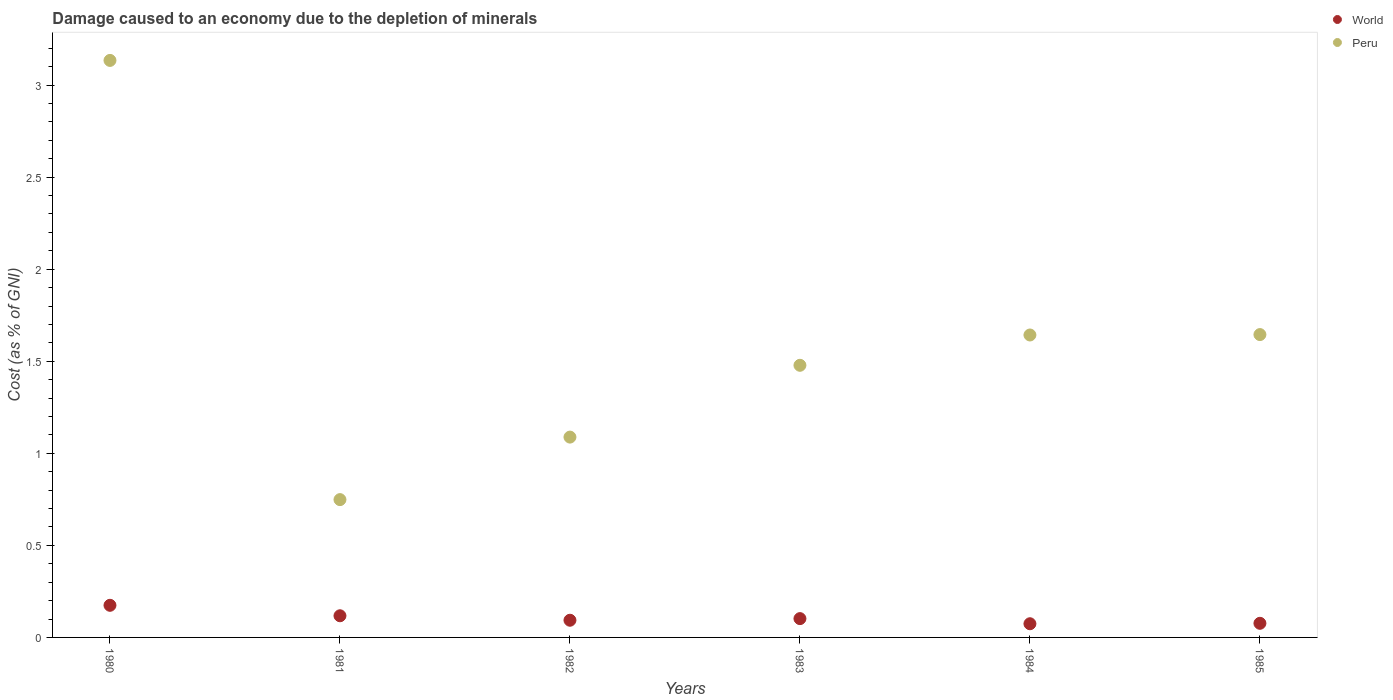Is the number of dotlines equal to the number of legend labels?
Keep it short and to the point. Yes. What is the cost of damage caused due to the depletion of minerals in Peru in 1981?
Ensure brevity in your answer.  0.75. Across all years, what is the maximum cost of damage caused due to the depletion of minerals in Peru?
Offer a very short reply. 3.13. Across all years, what is the minimum cost of damage caused due to the depletion of minerals in Peru?
Keep it short and to the point. 0.75. In which year was the cost of damage caused due to the depletion of minerals in World minimum?
Keep it short and to the point. 1984. What is the total cost of damage caused due to the depletion of minerals in World in the graph?
Your answer should be very brief. 0.64. What is the difference between the cost of damage caused due to the depletion of minerals in Peru in 1980 and that in 1982?
Your response must be concise. 2.05. What is the difference between the cost of damage caused due to the depletion of minerals in World in 1984 and the cost of damage caused due to the depletion of minerals in Peru in 1980?
Provide a short and direct response. -3.06. What is the average cost of damage caused due to the depletion of minerals in Peru per year?
Offer a very short reply. 1.62. In the year 1981, what is the difference between the cost of damage caused due to the depletion of minerals in Peru and cost of damage caused due to the depletion of minerals in World?
Ensure brevity in your answer.  0.63. In how many years, is the cost of damage caused due to the depletion of minerals in World greater than 2.5 %?
Offer a very short reply. 0. What is the ratio of the cost of damage caused due to the depletion of minerals in Peru in 1984 to that in 1985?
Ensure brevity in your answer.  1. Is the cost of damage caused due to the depletion of minerals in Peru in 1980 less than that in 1984?
Ensure brevity in your answer.  No. Is the difference between the cost of damage caused due to the depletion of minerals in Peru in 1982 and 1983 greater than the difference between the cost of damage caused due to the depletion of minerals in World in 1982 and 1983?
Your answer should be very brief. No. What is the difference between the highest and the second highest cost of damage caused due to the depletion of minerals in World?
Offer a very short reply. 0.06. What is the difference between the highest and the lowest cost of damage caused due to the depletion of minerals in World?
Offer a terse response. 0.1. In how many years, is the cost of damage caused due to the depletion of minerals in World greater than the average cost of damage caused due to the depletion of minerals in World taken over all years?
Offer a terse response. 2. Is the sum of the cost of damage caused due to the depletion of minerals in Peru in 1984 and 1985 greater than the maximum cost of damage caused due to the depletion of minerals in World across all years?
Provide a short and direct response. Yes. Does the cost of damage caused due to the depletion of minerals in World monotonically increase over the years?
Make the answer very short. No. Is the cost of damage caused due to the depletion of minerals in World strictly less than the cost of damage caused due to the depletion of minerals in Peru over the years?
Your response must be concise. Yes. How many dotlines are there?
Ensure brevity in your answer.  2. How many years are there in the graph?
Provide a short and direct response. 6. What is the difference between two consecutive major ticks on the Y-axis?
Your answer should be very brief. 0.5. Does the graph contain any zero values?
Your answer should be very brief. No. Does the graph contain grids?
Your response must be concise. No. Where does the legend appear in the graph?
Offer a very short reply. Top right. How are the legend labels stacked?
Your answer should be very brief. Vertical. What is the title of the graph?
Give a very brief answer. Damage caused to an economy due to the depletion of minerals. What is the label or title of the X-axis?
Your answer should be compact. Years. What is the label or title of the Y-axis?
Offer a very short reply. Cost (as % of GNI). What is the Cost (as % of GNI) of World in 1980?
Ensure brevity in your answer.  0.17. What is the Cost (as % of GNI) in Peru in 1980?
Your response must be concise. 3.13. What is the Cost (as % of GNI) of World in 1981?
Give a very brief answer. 0.12. What is the Cost (as % of GNI) of Peru in 1981?
Keep it short and to the point. 0.75. What is the Cost (as % of GNI) in World in 1982?
Your answer should be compact. 0.09. What is the Cost (as % of GNI) of Peru in 1982?
Provide a succinct answer. 1.09. What is the Cost (as % of GNI) of World in 1983?
Offer a very short reply. 0.1. What is the Cost (as % of GNI) in Peru in 1983?
Offer a very short reply. 1.48. What is the Cost (as % of GNI) in World in 1984?
Your answer should be very brief. 0.07. What is the Cost (as % of GNI) in Peru in 1984?
Keep it short and to the point. 1.64. What is the Cost (as % of GNI) in World in 1985?
Provide a short and direct response. 0.08. What is the Cost (as % of GNI) in Peru in 1985?
Offer a terse response. 1.64. Across all years, what is the maximum Cost (as % of GNI) in World?
Your answer should be compact. 0.17. Across all years, what is the maximum Cost (as % of GNI) of Peru?
Keep it short and to the point. 3.13. Across all years, what is the minimum Cost (as % of GNI) of World?
Keep it short and to the point. 0.07. Across all years, what is the minimum Cost (as % of GNI) of Peru?
Keep it short and to the point. 0.75. What is the total Cost (as % of GNI) in World in the graph?
Ensure brevity in your answer.  0.64. What is the total Cost (as % of GNI) of Peru in the graph?
Give a very brief answer. 9.74. What is the difference between the Cost (as % of GNI) of World in 1980 and that in 1981?
Keep it short and to the point. 0.06. What is the difference between the Cost (as % of GNI) of Peru in 1980 and that in 1981?
Ensure brevity in your answer.  2.39. What is the difference between the Cost (as % of GNI) in World in 1980 and that in 1982?
Make the answer very short. 0.08. What is the difference between the Cost (as % of GNI) of Peru in 1980 and that in 1982?
Keep it short and to the point. 2.05. What is the difference between the Cost (as % of GNI) of World in 1980 and that in 1983?
Your answer should be very brief. 0.07. What is the difference between the Cost (as % of GNI) of Peru in 1980 and that in 1983?
Your response must be concise. 1.66. What is the difference between the Cost (as % of GNI) in World in 1980 and that in 1984?
Offer a terse response. 0.1. What is the difference between the Cost (as % of GNI) of Peru in 1980 and that in 1984?
Make the answer very short. 1.49. What is the difference between the Cost (as % of GNI) in World in 1980 and that in 1985?
Keep it short and to the point. 0.1. What is the difference between the Cost (as % of GNI) of Peru in 1980 and that in 1985?
Make the answer very short. 1.49. What is the difference between the Cost (as % of GNI) of World in 1981 and that in 1982?
Your response must be concise. 0.02. What is the difference between the Cost (as % of GNI) in Peru in 1981 and that in 1982?
Provide a short and direct response. -0.34. What is the difference between the Cost (as % of GNI) in World in 1981 and that in 1983?
Provide a succinct answer. 0.02. What is the difference between the Cost (as % of GNI) in Peru in 1981 and that in 1983?
Your answer should be very brief. -0.73. What is the difference between the Cost (as % of GNI) in World in 1981 and that in 1984?
Give a very brief answer. 0.04. What is the difference between the Cost (as % of GNI) of Peru in 1981 and that in 1984?
Make the answer very short. -0.89. What is the difference between the Cost (as % of GNI) in World in 1981 and that in 1985?
Your response must be concise. 0.04. What is the difference between the Cost (as % of GNI) in Peru in 1981 and that in 1985?
Offer a very short reply. -0.9. What is the difference between the Cost (as % of GNI) of World in 1982 and that in 1983?
Keep it short and to the point. -0.01. What is the difference between the Cost (as % of GNI) in Peru in 1982 and that in 1983?
Offer a terse response. -0.39. What is the difference between the Cost (as % of GNI) in World in 1982 and that in 1984?
Your answer should be very brief. 0.02. What is the difference between the Cost (as % of GNI) of Peru in 1982 and that in 1984?
Offer a terse response. -0.55. What is the difference between the Cost (as % of GNI) of World in 1982 and that in 1985?
Your answer should be compact. 0.02. What is the difference between the Cost (as % of GNI) in Peru in 1982 and that in 1985?
Your response must be concise. -0.56. What is the difference between the Cost (as % of GNI) in World in 1983 and that in 1984?
Provide a succinct answer. 0.03. What is the difference between the Cost (as % of GNI) in Peru in 1983 and that in 1984?
Keep it short and to the point. -0.16. What is the difference between the Cost (as % of GNI) of World in 1983 and that in 1985?
Provide a short and direct response. 0.03. What is the difference between the Cost (as % of GNI) of Peru in 1983 and that in 1985?
Keep it short and to the point. -0.17. What is the difference between the Cost (as % of GNI) of World in 1984 and that in 1985?
Keep it short and to the point. -0. What is the difference between the Cost (as % of GNI) of Peru in 1984 and that in 1985?
Provide a succinct answer. -0. What is the difference between the Cost (as % of GNI) in World in 1980 and the Cost (as % of GNI) in Peru in 1981?
Your answer should be very brief. -0.57. What is the difference between the Cost (as % of GNI) in World in 1980 and the Cost (as % of GNI) in Peru in 1982?
Provide a succinct answer. -0.91. What is the difference between the Cost (as % of GNI) of World in 1980 and the Cost (as % of GNI) of Peru in 1983?
Provide a succinct answer. -1.3. What is the difference between the Cost (as % of GNI) of World in 1980 and the Cost (as % of GNI) of Peru in 1984?
Your response must be concise. -1.47. What is the difference between the Cost (as % of GNI) of World in 1980 and the Cost (as % of GNI) of Peru in 1985?
Your answer should be very brief. -1.47. What is the difference between the Cost (as % of GNI) in World in 1981 and the Cost (as % of GNI) in Peru in 1982?
Your response must be concise. -0.97. What is the difference between the Cost (as % of GNI) in World in 1981 and the Cost (as % of GNI) in Peru in 1983?
Provide a succinct answer. -1.36. What is the difference between the Cost (as % of GNI) of World in 1981 and the Cost (as % of GNI) of Peru in 1984?
Offer a very short reply. -1.53. What is the difference between the Cost (as % of GNI) in World in 1981 and the Cost (as % of GNI) in Peru in 1985?
Your answer should be very brief. -1.53. What is the difference between the Cost (as % of GNI) of World in 1982 and the Cost (as % of GNI) of Peru in 1983?
Offer a terse response. -1.38. What is the difference between the Cost (as % of GNI) in World in 1982 and the Cost (as % of GNI) in Peru in 1984?
Provide a succinct answer. -1.55. What is the difference between the Cost (as % of GNI) of World in 1982 and the Cost (as % of GNI) of Peru in 1985?
Your answer should be compact. -1.55. What is the difference between the Cost (as % of GNI) of World in 1983 and the Cost (as % of GNI) of Peru in 1984?
Offer a terse response. -1.54. What is the difference between the Cost (as % of GNI) of World in 1983 and the Cost (as % of GNI) of Peru in 1985?
Your answer should be very brief. -1.54. What is the difference between the Cost (as % of GNI) in World in 1984 and the Cost (as % of GNI) in Peru in 1985?
Ensure brevity in your answer.  -1.57. What is the average Cost (as % of GNI) of World per year?
Your response must be concise. 0.11. What is the average Cost (as % of GNI) in Peru per year?
Keep it short and to the point. 1.62. In the year 1980, what is the difference between the Cost (as % of GNI) of World and Cost (as % of GNI) of Peru?
Provide a succinct answer. -2.96. In the year 1981, what is the difference between the Cost (as % of GNI) of World and Cost (as % of GNI) of Peru?
Provide a short and direct response. -0.63. In the year 1982, what is the difference between the Cost (as % of GNI) of World and Cost (as % of GNI) of Peru?
Ensure brevity in your answer.  -0.99. In the year 1983, what is the difference between the Cost (as % of GNI) in World and Cost (as % of GNI) in Peru?
Offer a terse response. -1.38. In the year 1984, what is the difference between the Cost (as % of GNI) in World and Cost (as % of GNI) in Peru?
Keep it short and to the point. -1.57. In the year 1985, what is the difference between the Cost (as % of GNI) of World and Cost (as % of GNI) of Peru?
Ensure brevity in your answer.  -1.57. What is the ratio of the Cost (as % of GNI) in World in 1980 to that in 1981?
Give a very brief answer. 1.48. What is the ratio of the Cost (as % of GNI) of Peru in 1980 to that in 1981?
Give a very brief answer. 4.19. What is the ratio of the Cost (as % of GNI) in World in 1980 to that in 1982?
Ensure brevity in your answer.  1.87. What is the ratio of the Cost (as % of GNI) of Peru in 1980 to that in 1982?
Give a very brief answer. 2.88. What is the ratio of the Cost (as % of GNI) in World in 1980 to that in 1983?
Your answer should be very brief. 1.71. What is the ratio of the Cost (as % of GNI) in Peru in 1980 to that in 1983?
Your response must be concise. 2.12. What is the ratio of the Cost (as % of GNI) of World in 1980 to that in 1984?
Make the answer very short. 2.35. What is the ratio of the Cost (as % of GNI) of Peru in 1980 to that in 1984?
Your answer should be compact. 1.91. What is the ratio of the Cost (as % of GNI) of World in 1980 to that in 1985?
Make the answer very short. 2.28. What is the ratio of the Cost (as % of GNI) of Peru in 1980 to that in 1985?
Your response must be concise. 1.91. What is the ratio of the Cost (as % of GNI) in World in 1981 to that in 1982?
Your answer should be very brief. 1.26. What is the ratio of the Cost (as % of GNI) in Peru in 1981 to that in 1982?
Give a very brief answer. 0.69. What is the ratio of the Cost (as % of GNI) of World in 1981 to that in 1983?
Make the answer very short. 1.15. What is the ratio of the Cost (as % of GNI) in Peru in 1981 to that in 1983?
Offer a very short reply. 0.51. What is the ratio of the Cost (as % of GNI) in World in 1981 to that in 1984?
Your answer should be very brief. 1.58. What is the ratio of the Cost (as % of GNI) of Peru in 1981 to that in 1984?
Your answer should be very brief. 0.46. What is the ratio of the Cost (as % of GNI) in World in 1981 to that in 1985?
Your response must be concise. 1.53. What is the ratio of the Cost (as % of GNI) of Peru in 1981 to that in 1985?
Ensure brevity in your answer.  0.46. What is the ratio of the Cost (as % of GNI) in World in 1982 to that in 1983?
Give a very brief answer. 0.91. What is the ratio of the Cost (as % of GNI) in Peru in 1982 to that in 1983?
Provide a succinct answer. 0.74. What is the ratio of the Cost (as % of GNI) in World in 1982 to that in 1984?
Make the answer very short. 1.26. What is the ratio of the Cost (as % of GNI) of Peru in 1982 to that in 1984?
Your answer should be very brief. 0.66. What is the ratio of the Cost (as % of GNI) in World in 1982 to that in 1985?
Provide a short and direct response. 1.22. What is the ratio of the Cost (as % of GNI) of Peru in 1982 to that in 1985?
Ensure brevity in your answer.  0.66. What is the ratio of the Cost (as % of GNI) of World in 1983 to that in 1984?
Keep it short and to the point. 1.37. What is the ratio of the Cost (as % of GNI) in Peru in 1983 to that in 1984?
Offer a terse response. 0.9. What is the ratio of the Cost (as % of GNI) of World in 1983 to that in 1985?
Provide a short and direct response. 1.33. What is the ratio of the Cost (as % of GNI) in Peru in 1983 to that in 1985?
Give a very brief answer. 0.9. What is the ratio of the Cost (as % of GNI) in World in 1984 to that in 1985?
Offer a very short reply. 0.97. What is the ratio of the Cost (as % of GNI) in Peru in 1984 to that in 1985?
Your response must be concise. 1. What is the difference between the highest and the second highest Cost (as % of GNI) in World?
Offer a terse response. 0.06. What is the difference between the highest and the second highest Cost (as % of GNI) in Peru?
Provide a succinct answer. 1.49. What is the difference between the highest and the lowest Cost (as % of GNI) in World?
Make the answer very short. 0.1. What is the difference between the highest and the lowest Cost (as % of GNI) of Peru?
Provide a succinct answer. 2.39. 